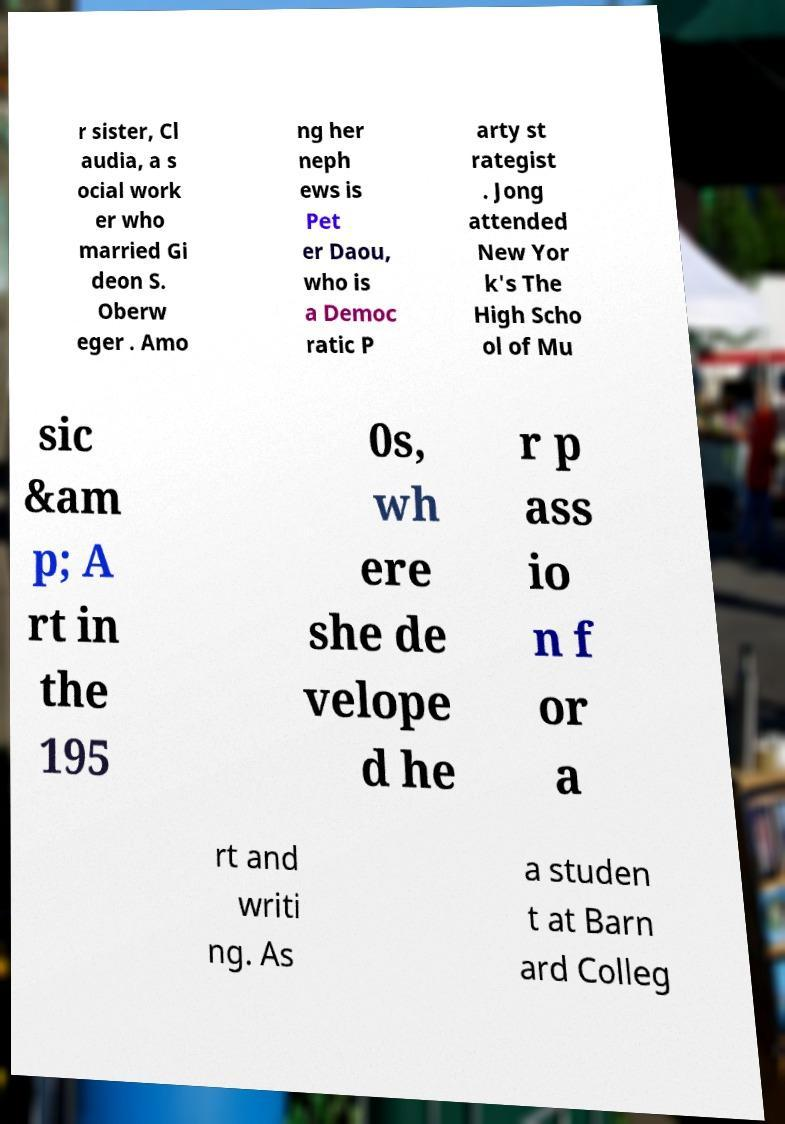Can you accurately transcribe the text from the provided image for me? r sister, Cl audia, a s ocial work er who married Gi deon S. Oberw eger . Amo ng her neph ews is Pet er Daou, who is a Democ ratic P arty st rategist . Jong attended New Yor k's The High Scho ol of Mu sic &am p; A rt in the 195 0s, wh ere she de velope d he r p ass io n f or a rt and writi ng. As a studen t at Barn ard Colleg 